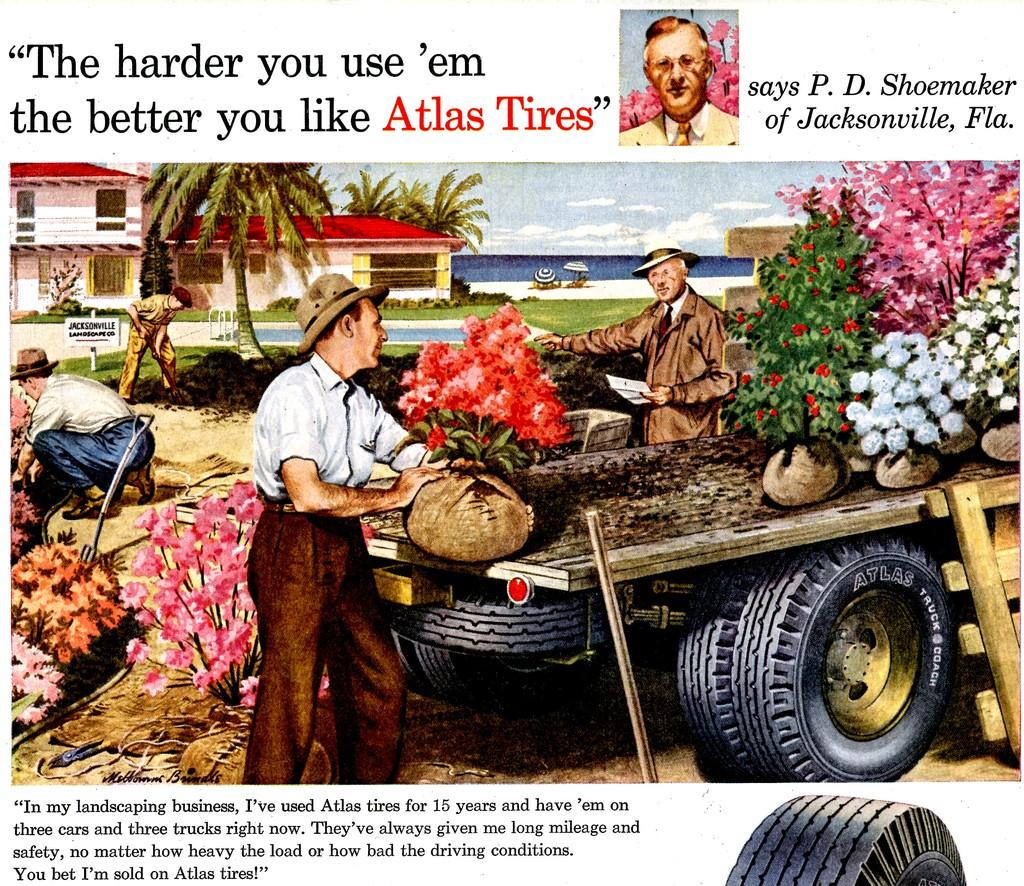What is present in the image related to visual communication? There is a poster in the image. What can be found on the poster besides text? The poster contains images. What type of information is conveyed through the poster? The poster contains text. How does the poster contribute to the quiet atmosphere in the image? The poster does not contribute to the quiet atmosphere in the image, as there is no mention of any sound or noise level in the provided facts. 